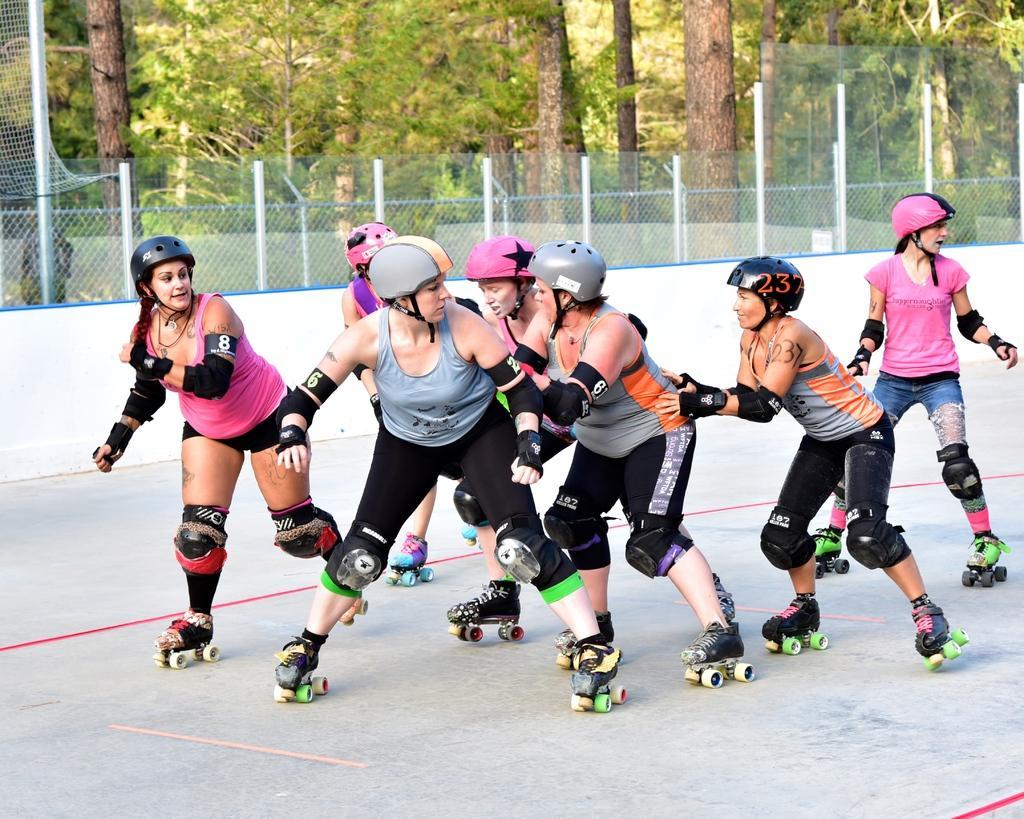Can you describe this image briefly? In this picture there are group of people skating. At the back there is a fence and there are trees. At the bottom there is a floor. 